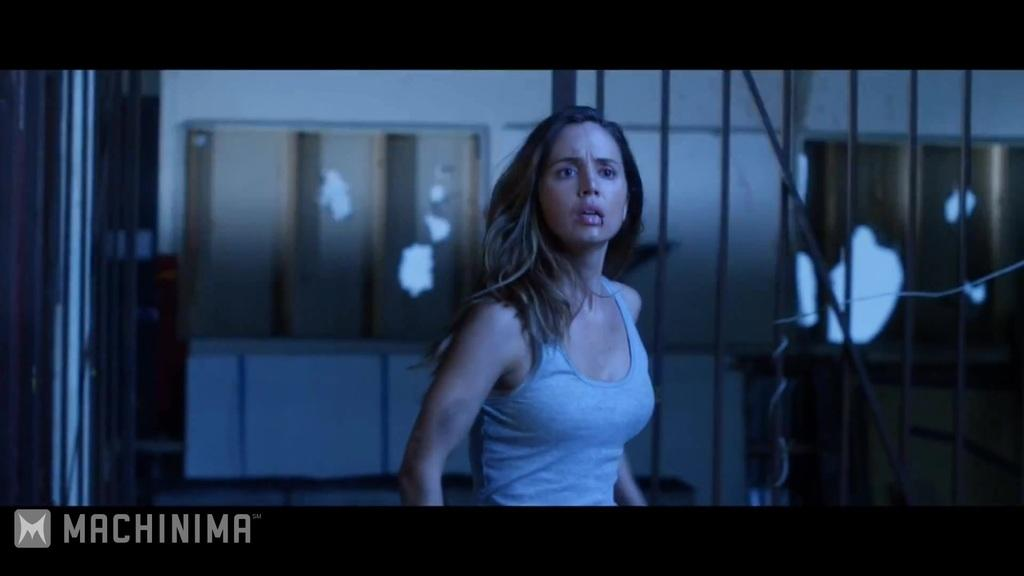What is the main subject of the image? There is a woman standing in the image. What can be seen in the background of the image? There is a fence, cupboards, and a wall in the background of the image. Can you describe any objects on the right side of the image? There is a cable on the right side of the image. Is there any text present in the image? Yes, there is text written at the bottom of the image. What songs is the woman singing in the image? There is no indication in the image that the woman is singing any songs. How many vacations does the woman have planned in the image? There is no information about vacations in the image. 